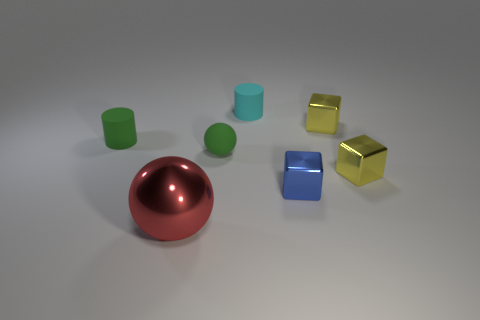Is the shape of the tiny rubber thing that is to the left of the big ball the same as the shiny thing on the left side of the small cyan object?
Your answer should be compact. No. How many other things are the same color as the rubber sphere?
Ensure brevity in your answer.  1. Does the cylinder right of the red thing have the same material as the green thing that is left of the big red shiny ball?
Ensure brevity in your answer.  Yes. Are there an equal number of things on the left side of the large metal thing and blue metal cubes on the left side of the small cyan matte thing?
Provide a succinct answer. No. There is a tiny cylinder to the left of the cyan thing; what material is it?
Ensure brevity in your answer.  Rubber. Is there anything else that has the same size as the rubber sphere?
Ensure brevity in your answer.  Yes. Is the number of tiny cylinders less than the number of small gray metallic balls?
Offer a very short reply. No. There is a rubber object that is behind the small rubber sphere and right of the big red object; what shape is it?
Provide a short and direct response. Cylinder. How many balls are there?
Give a very brief answer. 2. What material is the ball that is behind the metallic object that is left of the matte object to the right of the green sphere?
Ensure brevity in your answer.  Rubber. 